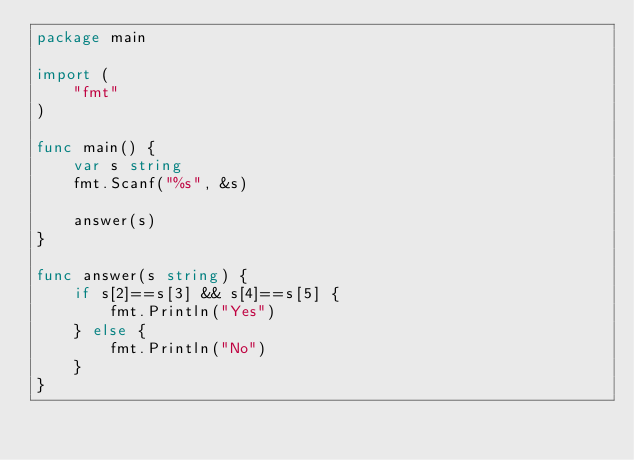Convert code to text. <code><loc_0><loc_0><loc_500><loc_500><_Go_>package main

import (
	"fmt"
)

func main() {
	var s string
	fmt.Scanf("%s", &s)

	answer(s)
}

func answer(s string) {
	if s[2]==s[3] && s[4]==s[5] {
		fmt.Println("Yes")
	} else {
		fmt.Println("No")
	}
}
</code> 